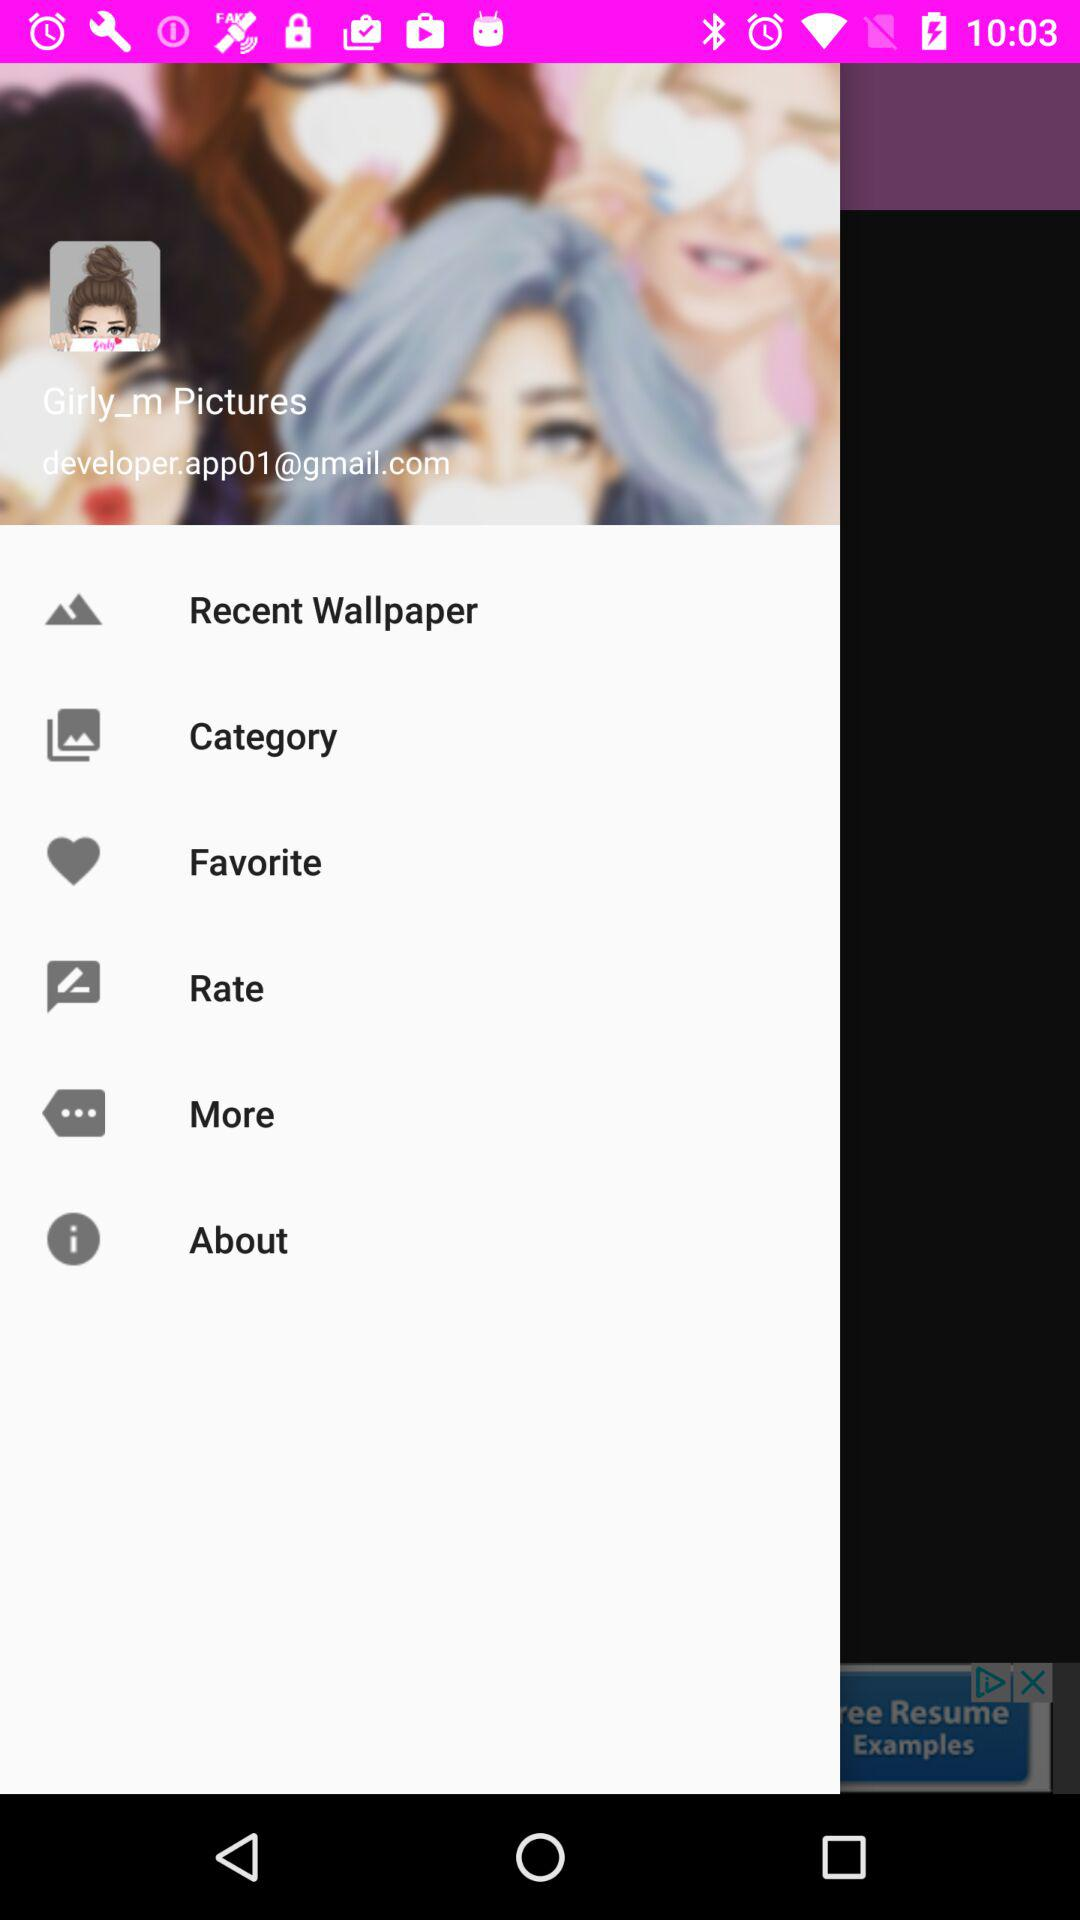What is the user's email address? The user's email address is developer.app01@gmail.com. 